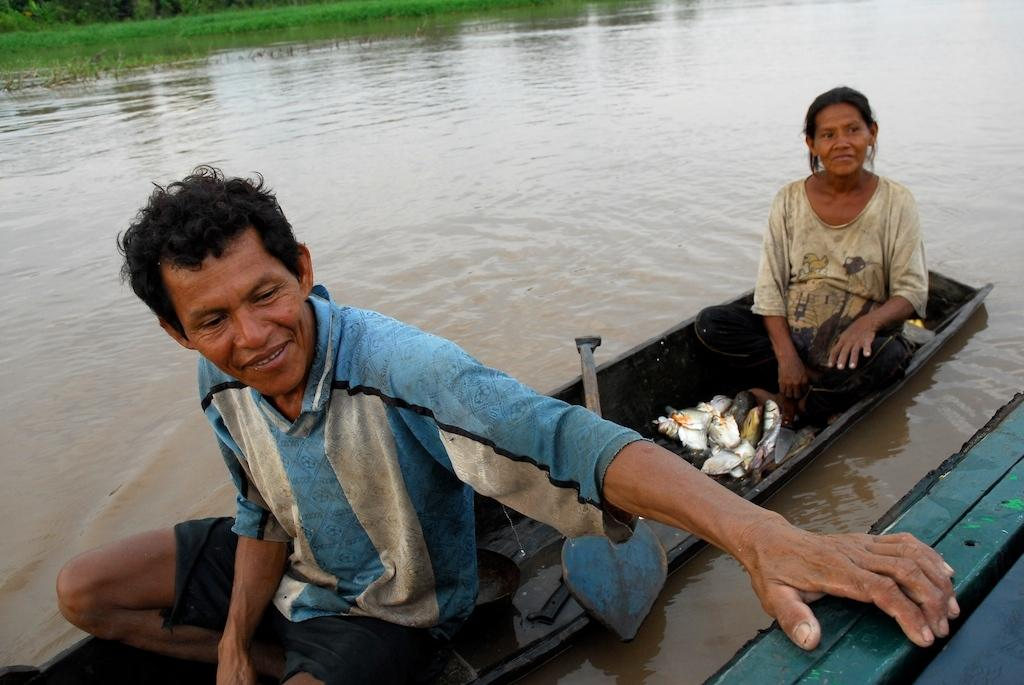How many people are in the image? There are two people in the image, a man and a woman. What are the man and woman doing in the image? The man and woman are sitting in a boat and smiling. What can be seen in the background of the image? There is water and grass visible in the image. What are the man and woman wearing? Both the man and woman are wearing clothes. What type of friction can be observed between the boat and the water in the image? There is no specific type of friction mentioned or observable in the image; it simply shows a boat on water with a man and woman inside. Can you tell me how many cans are visible in the image? There are no cans present in the image. 